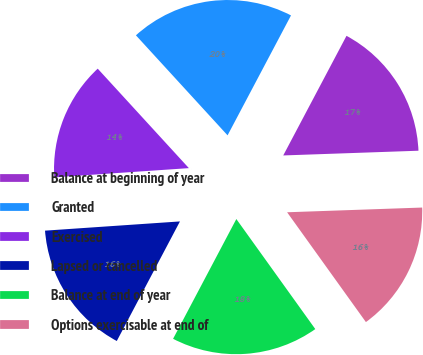Convert chart to OTSL. <chart><loc_0><loc_0><loc_500><loc_500><pie_chart><fcel>Balance at beginning of year<fcel>Granted<fcel>Exercised<fcel>Lapsed or cancelled<fcel>Balance at end of year<fcel>Options exercisable at end of<nl><fcel>16.7%<fcel>19.55%<fcel>14.28%<fcel>16.18%<fcel>17.64%<fcel>15.65%<nl></chart> 